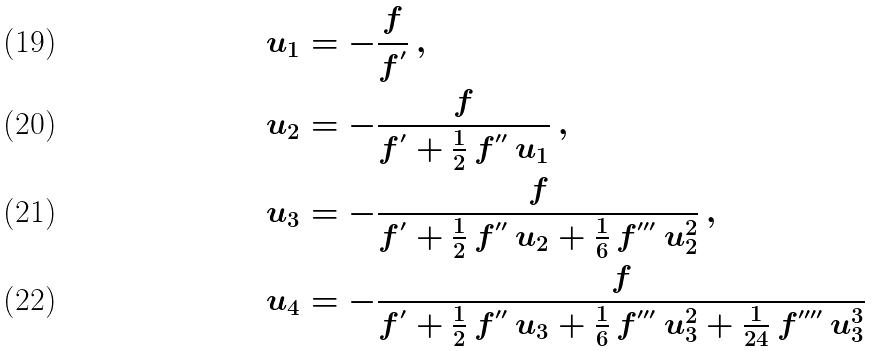Convert formula to latex. <formula><loc_0><loc_0><loc_500><loc_500>& u _ { 1 } = - \frac { f } { f ^ { ^ { \prime } } } \, , \\ & u _ { 2 } = - \frac { f } { f ^ { ^ { \prime } } + \frac { 1 } { 2 } \, f ^ { ^ { \prime \prime } } \, u _ { 1 } } \, , \\ & u _ { 3 } = - \frac { f } { f ^ { ^ { \prime } } + \frac { 1 } { 2 } \, f ^ { ^ { \prime \prime } } \, u _ { 2 } + \frac { 1 } { 6 } \, f ^ { ^ { \prime \prime \prime } } \, u _ { 2 } ^ { 2 } } \, , \\ & u _ { 4 } = - \frac { f } { f ^ { ^ { \prime } } + \frac { 1 } { 2 } \, f ^ { ^ { \prime \prime } } \, u _ { 3 } + \frac { 1 } { 6 } \, f ^ { ^ { \prime \prime \prime } } \, u _ { 3 } ^ { 2 } + \frac { 1 } { 2 4 } \, f ^ { ^ { \prime \prime \prime \prime } } \, u _ { 3 } ^ { 3 } }</formula> 